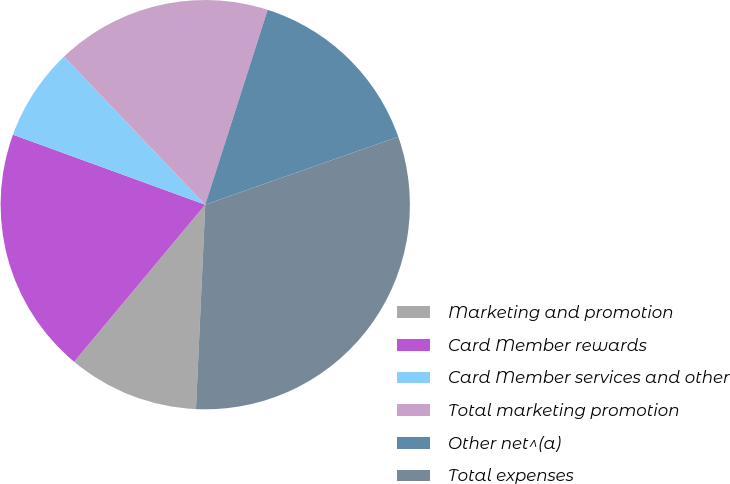Convert chart. <chart><loc_0><loc_0><loc_500><loc_500><pie_chart><fcel>Marketing and promotion<fcel>Card Member rewards<fcel>Card Member services and other<fcel>Total marketing promotion<fcel>Other net^(a)<fcel>Total expenses<nl><fcel>10.35%<fcel>19.49%<fcel>7.32%<fcel>17.06%<fcel>14.68%<fcel>31.11%<nl></chart> 